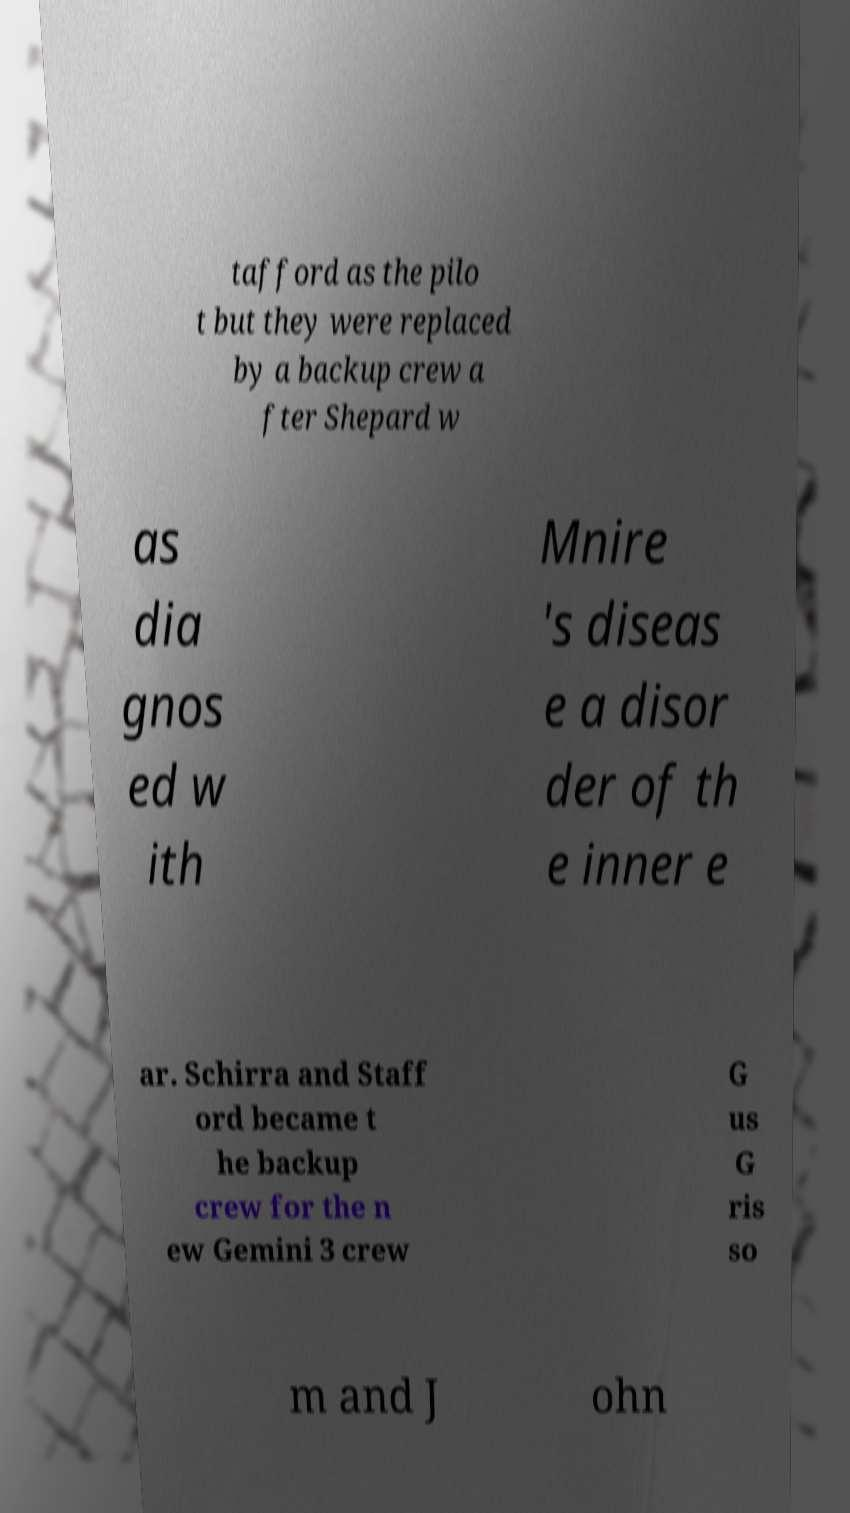For documentation purposes, I need the text within this image transcribed. Could you provide that? tafford as the pilo t but they were replaced by a backup crew a fter Shepard w as dia gnos ed w ith Mnire 's diseas e a disor der of th e inner e ar. Schirra and Staff ord became t he backup crew for the n ew Gemini 3 crew G us G ris so m and J ohn 